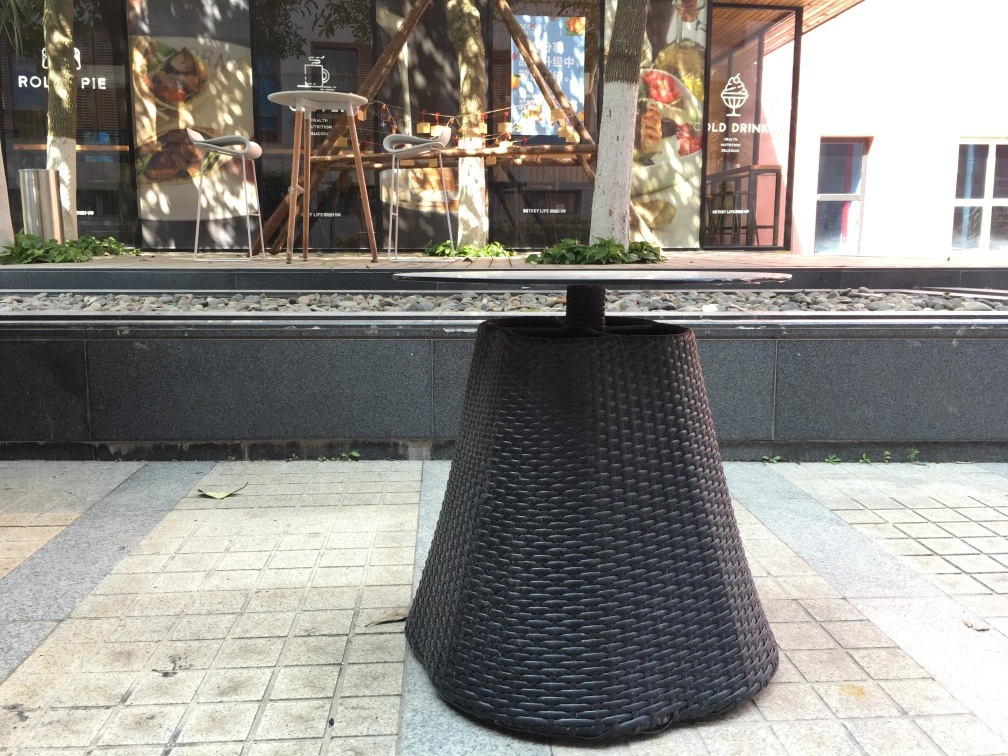Do the trees lack details in the image? The trees in the image exhibit a moderate level of detail. Although they are not the clearest element due to the focus being on the foreground, you can still discern individual leaves and branches, suggesting that the detail is sufficient under casual observation. 